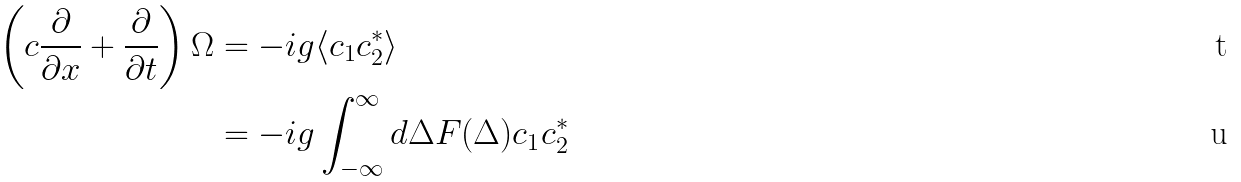Convert formula to latex. <formula><loc_0><loc_0><loc_500><loc_500>\left ( c \frac { \partial } { \partial x } + \frac { \partial } { \partial t } \right ) \Omega & = - i g \langle c _ { 1 } c _ { 2 } ^ { * } \rangle \\ & = - i g \int _ { - \infty } ^ { \infty } d \Delta F ( \Delta ) c _ { 1 } c _ { 2 } ^ { * }</formula> 